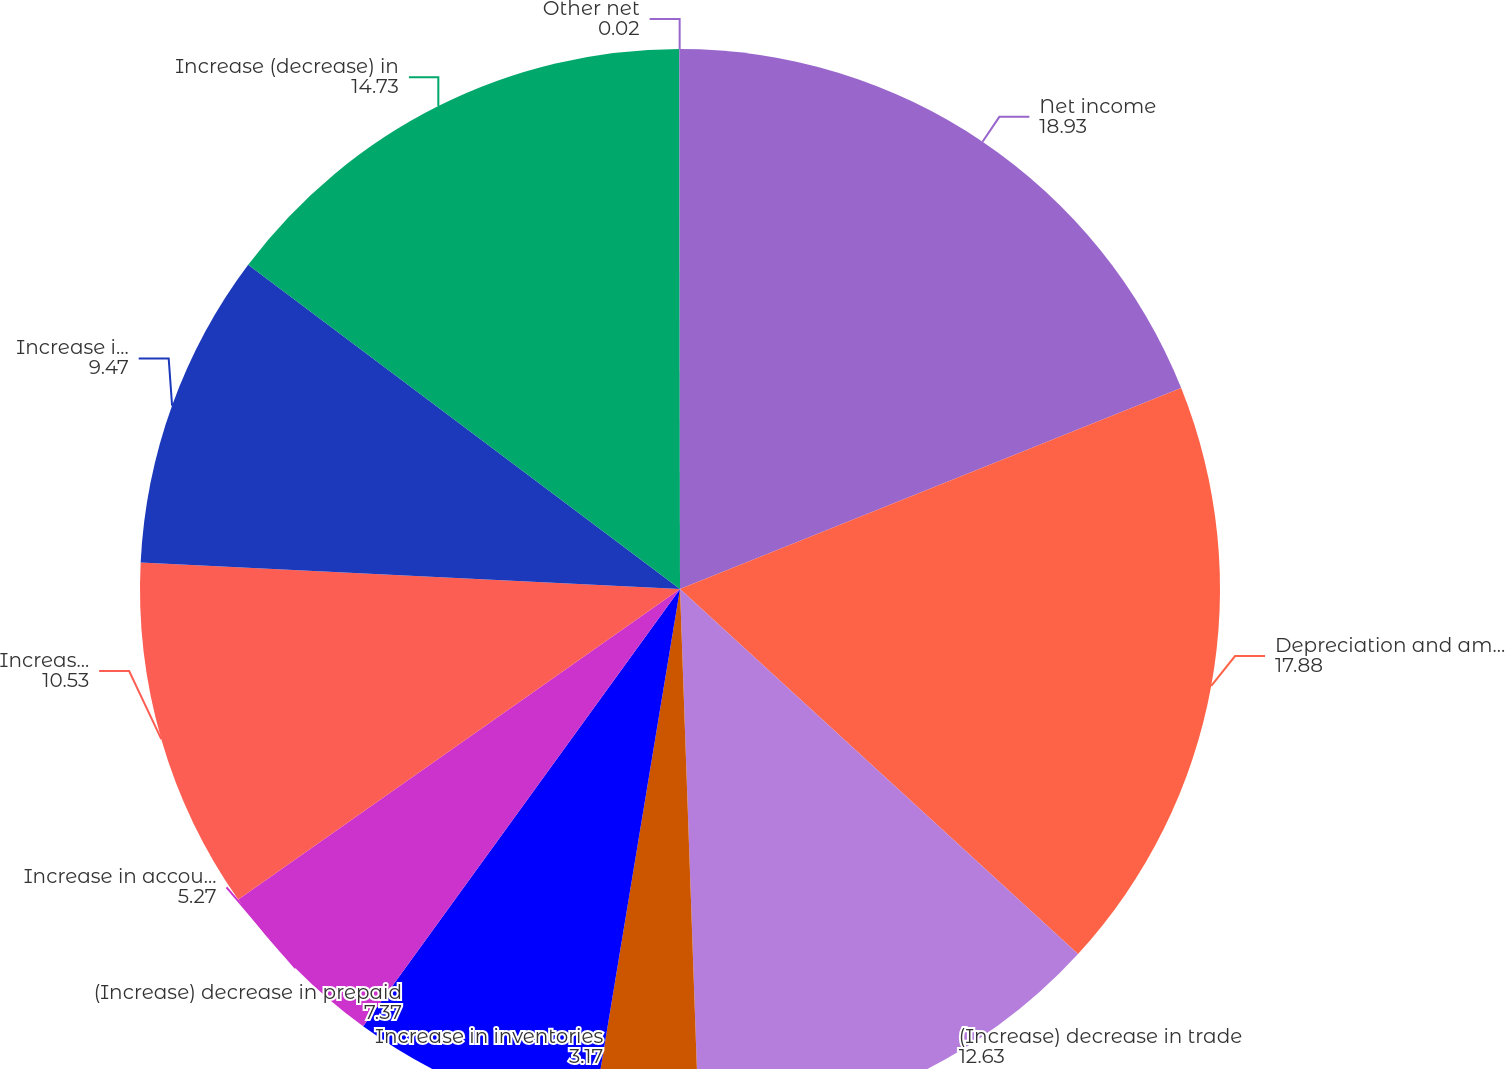<chart> <loc_0><loc_0><loc_500><loc_500><pie_chart><fcel>Net income<fcel>Depreciation and amortization<fcel>(Increase) decrease in trade<fcel>Increase in inventories<fcel>(Increase) decrease in prepaid<fcel>Increase in accounts payable<fcel>Increase (decrease) in accrued<fcel>Increase in accrued expenses<fcel>Increase (decrease) in<fcel>Other net<nl><fcel>18.93%<fcel>17.88%<fcel>12.63%<fcel>3.17%<fcel>7.37%<fcel>5.27%<fcel>10.53%<fcel>9.47%<fcel>14.73%<fcel>0.02%<nl></chart> 